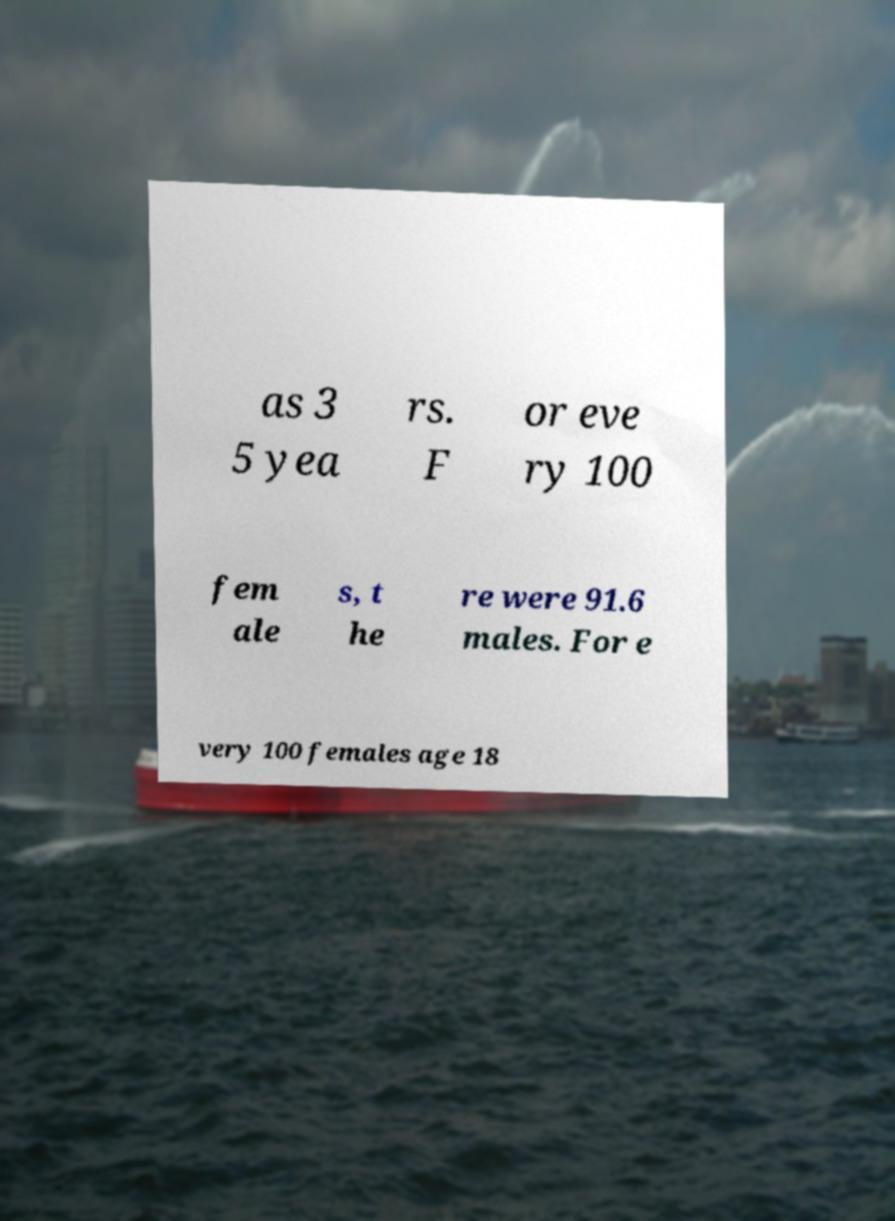Can you read and provide the text displayed in the image?This photo seems to have some interesting text. Can you extract and type it out for me? as 3 5 yea rs. F or eve ry 100 fem ale s, t he re were 91.6 males. For e very 100 females age 18 